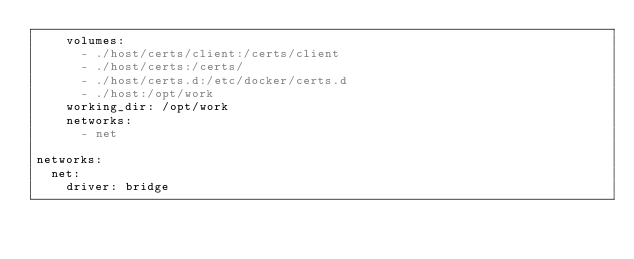Convert code to text. <code><loc_0><loc_0><loc_500><loc_500><_YAML_>    volumes:
      - ./host/certs/client:/certs/client
      - ./host/certs:/certs/
      - ./host/certs.d:/etc/docker/certs.d
      - ./host:/opt/work
    working_dir: /opt/work
    networks: 
      - net

networks: 
  net:
    driver: bridge</code> 